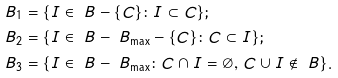<formula> <loc_0><loc_0><loc_500><loc_500>& \ B _ { 1 } = \{ I \in \ B - \{ C \} \colon I \subset C \} ; \\ & \ B _ { 2 } = \{ I \in \ B - \ B _ { \max } - \{ C \} \colon C \subset I \} ; \\ & \ B _ { 3 } = \{ I \in \ B - \ B _ { \max } \colon C \cap I = \emptyset , \, C \cup I \notin \ B \} .</formula> 